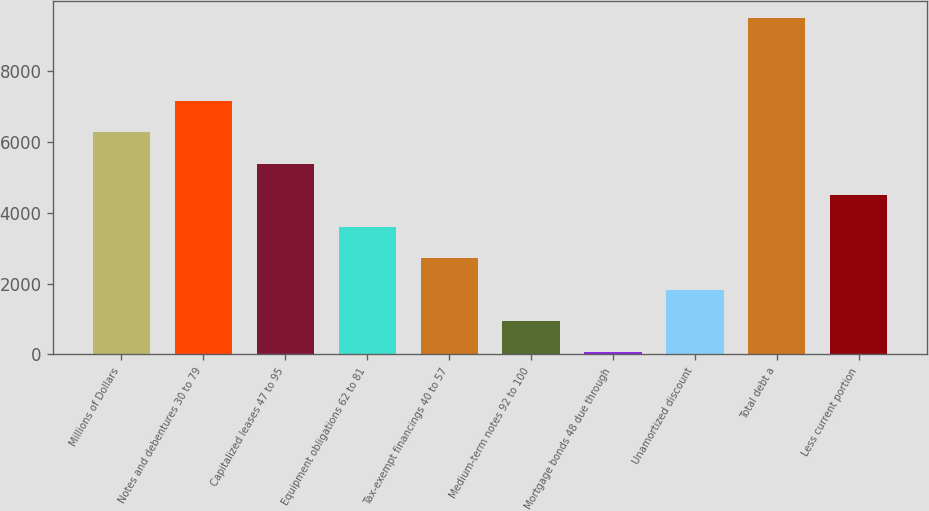<chart> <loc_0><loc_0><loc_500><loc_500><bar_chart><fcel>Millions of Dollars<fcel>Notes and debentures 30 to 79<fcel>Capitalized leases 47 to 95<fcel>Equipment obligations 62 to 81<fcel>Tax-exempt financings 40 to 57<fcel>Medium-term notes 92 to 100<fcel>Mortgage bonds 48 due through<fcel>Unamortized discount<fcel>Total debt a<fcel>Less current portion<nl><fcel>6266.3<fcel>7153.2<fcel>5379.4<fcel>3605.6<fcel>2718.7<fcel>944.9<fcel>58<fcel>1831.8<fcel>9493.9<fcel>4492.5<nl></chart> 